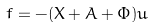Convert formula to latex. <formula><loc_0><loc_0><loc_500><loc_500>f = - ( X + A + \Phi ) u</formula> 